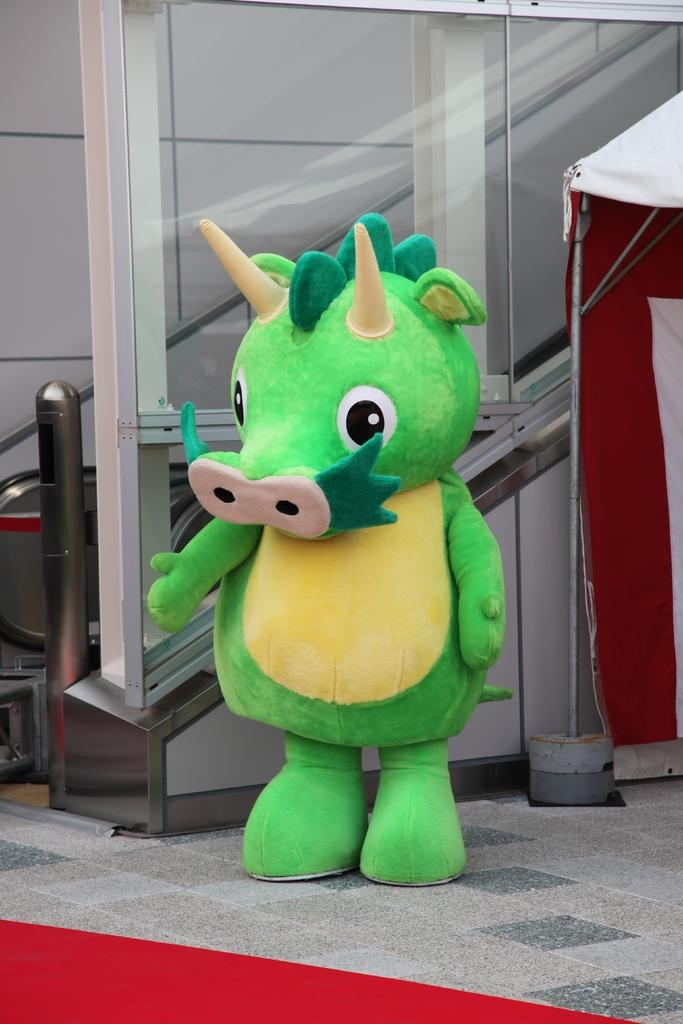What type of character can be seen in the image? There is a clown in the image. What kind of structure is present in the image? There is an escalator and a tent in the image. What is the purpose of the stand in the image? The purpose of the stand in the image is not specified, but it could be used for selling items or providing information. What is the lowest part of the image? There is a floor at the bottom of the image. How does the clown's low nerve affect the image? There is no mention of the clown's nerve in the image, so it cannot be determined how it might affect the image. 